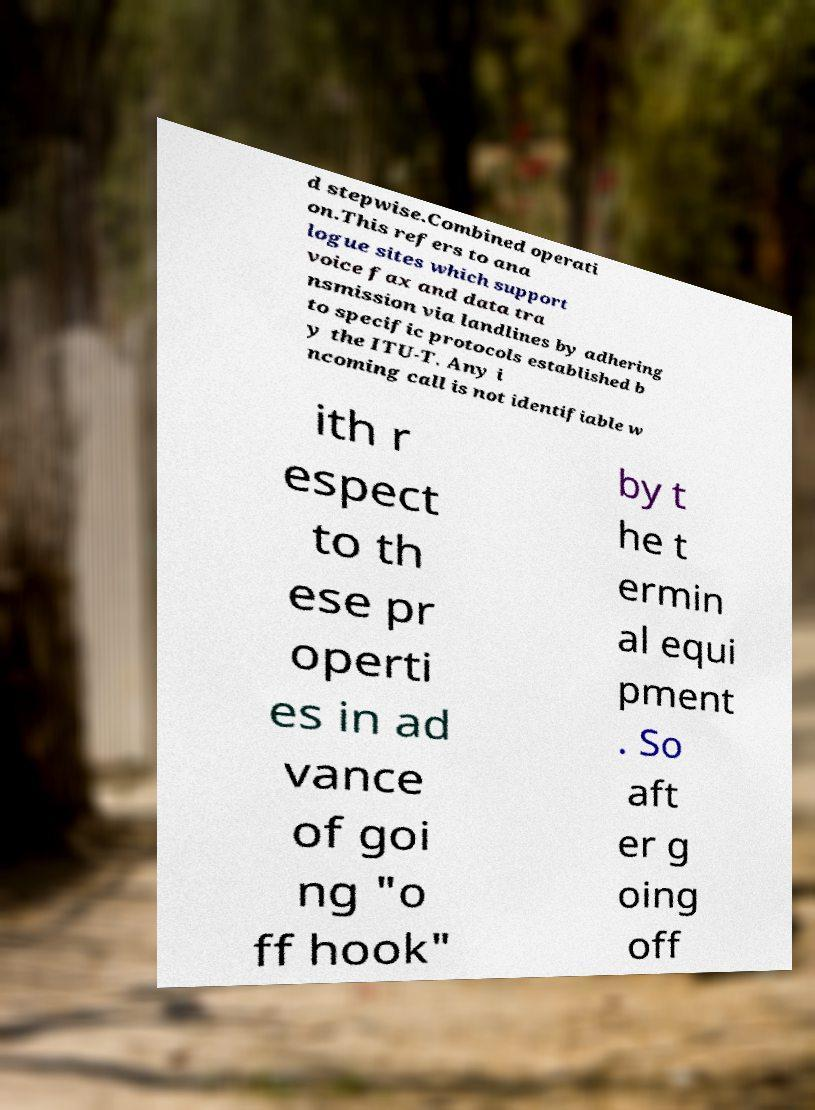What messages or text are displayed in this image? I need them in a readable, typed format. d stepwise.Combined operati on.This refers to ana logue sites which support voice fax and data tra nsmission via landlines by adhering to specific protocols established b y the ITU-T. Any i ncoming call is not identifiable w ith r espect to th ese pr operti es in ad vance of goi ng "o ff hook" by t he t ermin al equi pment . So aft er g oing off 